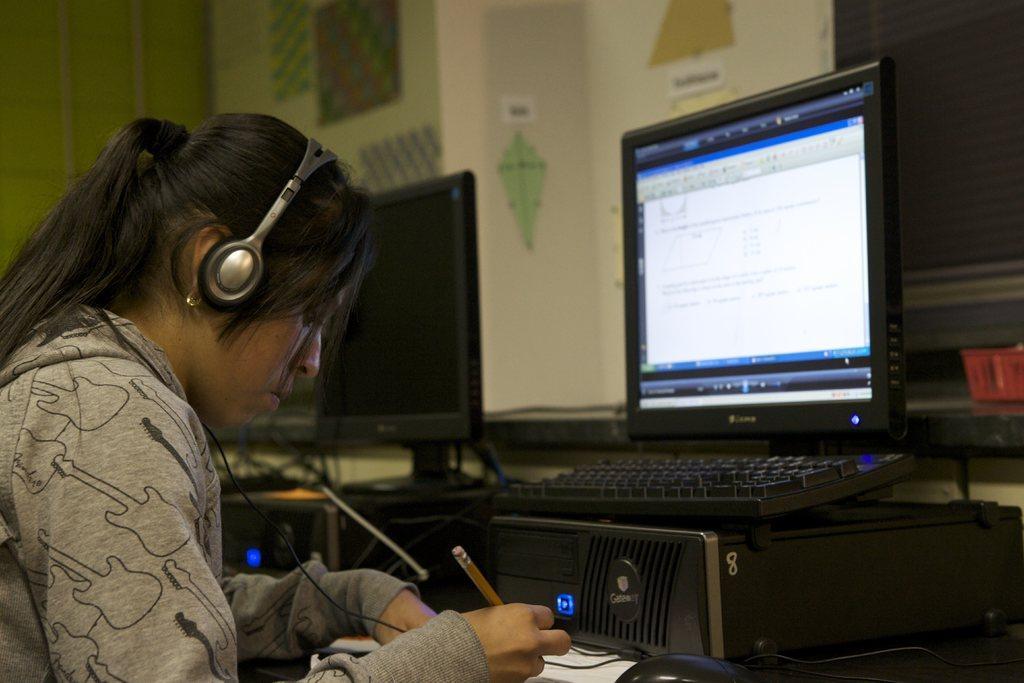Could you give a brief overview of what you see in this image? On the left side of the image we can see a woman and she is holding a pen, in front of her we can see monitors, keyboard, mouse and other things on the table, at the top of the image we can see posters on the wall. 